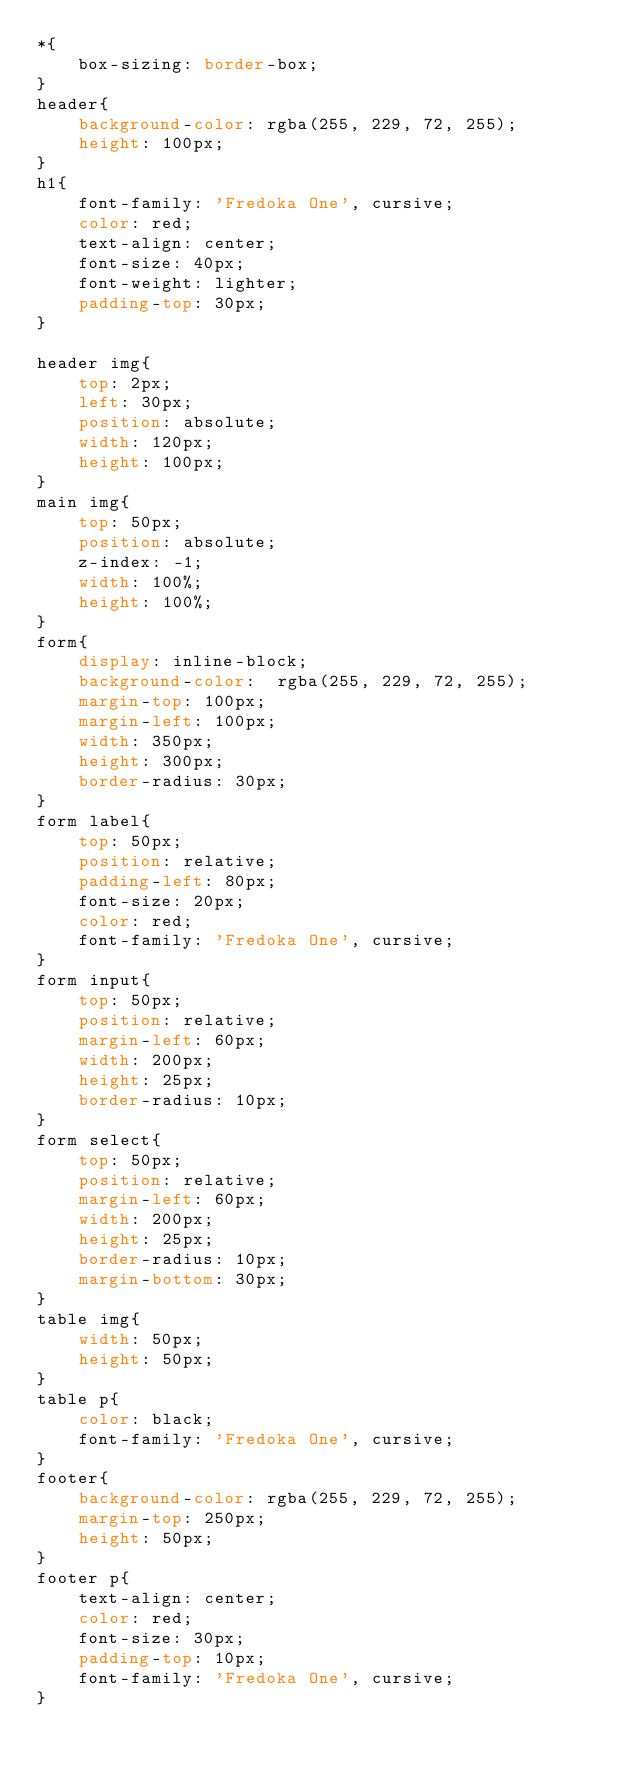<code> <loc_0><loc_0><loc_500><loc_500><_CSS_>*{
    box-sizing: border-box;
}
header{
    background-color: rgba(255, 229, 72, 255);
    height: 100px;
}
h1{
    font-family: 'Fredoka One', cursive;
    color: red;
    text-align: center;
    font-size: 40px;
    font-weight: lighter;
    padding-top: 30px;
}

header img{
    top: 2px;
    left: 30px;
    position: absolute;
    width: 120px;
    height: 100px;
}
main img{
    top: 50px;
    position: absolute;
    z-index: -1;
    width: 100%;
    height: 100%;
}
form{
    display: inline-block;
    background-color:  rgba(255, 229, 72, 255);
    margin-top: 100px;
    margin-left: 100px;
    width: 350px;
    height: 300px;
    border-radius: 30px;
}
form label{
    top: 50px;
    position: relative;
    padding-left: 80px;
    font-size: 20px;
    color: red;
    font-family: 'Fredoka One', cursive;
}
form input{
    top: 50px;
    position: relative;
    margin-left: 60px;
    width: 200px;
    height: 25px;
    border-radius: 10px;
}
form select{
    top: 50px;
    position: relative;
    margin-left: 60px;
    width: 200px;
    height: 25px;
    border-radius: 10px;
    margin-bottom: 30px;
}
table img{
    width: 50px;
    height: 50px;
}
table p{
    color: black;
    font-family: 'Fredoka One', cursive;
}
footer{
    background-color: rgba(255, 229, 72, 255);
    margin-top: 250px;
    height: 50px;
}
footer p{
    text-align: center;
    color: red;
    font-size: 30px;
    padding-top: 10px;
    font-family: 'Fredoka One', cursive;
}</code> 